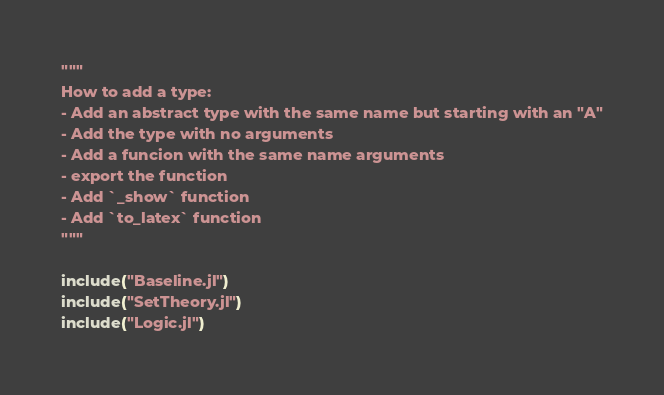Convert code to text. <code><loc_0><loc_0><loc_500><loc_500><_Julia_>"""
How to add a type:
- Add an abstract type with the same name but starting with an "A"
- Add the type with no arguments
- Add a funcion with the same name arguments
- export the function
- Add `_show` function
- Add `to_latex` function
"""

include("Baseline.jl")
include("SetTheory.jl")
include("Logic.jl")
</code> 